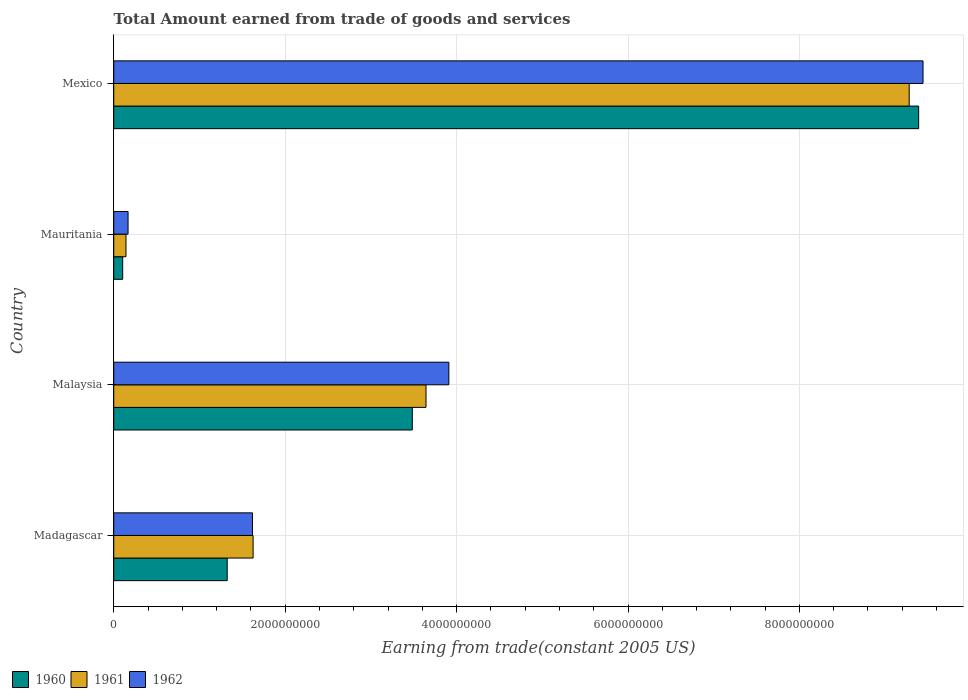How many different coloured bars are there?
Offer a very short reply. 3. How many groups of bars are there?
Ensure brevity in your answer.  4. Are the number of bars on each tick of the Y-axis equal?
Your answer should be compact. Yes. How many bars are there on the 1st tick from the bottom?
Ensure brevity in your answer.  3. What is the label of the 4th group of bars from the top?
Offer a terse response. Madagascar. What is the total amount earned by trading goods and services in 1961 in Mauritania?
Your answer should be compact. 1.43e+08. Across all countries, what is the maximum total amount earned by trading goods and services in 1960?
Your response must be concise. 9.39e+09. Across all countries, what is the minimum total amount earned by trading goods and services in 1962?
Your answer should be very brief. 1.67e+08. In which country was the total amount earned by trading goods and services in 1962 maximum?
Offer a very short reply. Mexico. In which country was the total amount earned by trading goods and services in 1960 minimum?
Make the answer very short. Mauritania. What is the total total amount earned by trading goods and services in 1960 in the graph?
Your answer should be very brief. 1.43e+1. What is the difference between the total amount earned by trading goods and services in 1961 in Madagascar and that in Mauritania?
Offer a very short reply. 1.48e+09. What is the difference between the total amount earned by trading goods and services in 1960 in Malaysia and the total amount earned by trading goods and services in 1962 in Mauritania?
Give a very brief answer. 3.32e+09. What is the average total amount earned by trading goods and services in 1962 per country?
Give a very brief answer. 3.78e+09. What is the difference between the total amount earned by trading goods and services in 1960 and total amount earned by trading goods and services in 1961 in Mauritania?
Offer a very short reply. -3.85e+07. In how many countries, is the total amount earned by trading goods and services in 1962 greater than 6800000000 US$?
Make the answer very short. 1. What is the ratio of the total amount earned by trading goods and services in 1960 in Madagascar to that in Mexico?
Provide a succinct answer. 0.14. Is the total amount earned by trading goods and services in 1960 in Mauritania less than that in Mexico?
Your answer should be very brief. Yes. What is the difference between the highest and the second highest total amount earned by trading goods and services in 1960?
Keep it short and to the point. 5.91e+09. What is the difference between the highest and the lowest total amount earned by trading goods and services in 1960?
Offer a very short reply. 9.29e+09. In how many countries, is the total amount earned by trading goods and services in 1962 greater than the average total amount earned by trading goods and services in 1962 taken over all countries?
Offer a terse response. 2. What does the 2nd bar from the top in Mauritania represents?
Make the answer very short. 1961. What does the 3rd bar from the bottom in Mexico represents?
Ensure brevity in your answer.  1962. Is it the case that in every country, the sum of the total amount earned by trading goods and services in 1962 and total amount earned by trading goods and services in 1960 is greater than the total amount earned by trading goods and services in 1961?
Offer a terse response. Yes. How many bars are there?
Your answer should be very brief. 12. Are all the bars in the graph horizontal?
Offer a terse response. Yes. How many countries are there in the graph?
Give a very brief answer. 4. Where does the legend appear in the graph?
Your response must be concise. Bottom left. What is the title of the graph?
Make the answer very short. Total Amount earned from trade of goods and services. What is the label or title of the X-axis?
Your answer should be very brief. Earning from trade(constant 2005 US). What is the label or title of the Y-axis?
Keep it short and to the point. Country. What is the Earning from trade(constant 2005 US) in 1960 in Madagascar?
Provide a succinct answer. 1.32e+09. What is the Earning from trade(constant 2005 US) in 1961 in Madagascar?
Provide a short and direct response. 1.63e+09. What is the Earning from trade(constant 2005 US) in 1962 in Madagascar?
Ensure brevity in your answer.  1.62e+09. What is the Earning from trade(constant 2005 US) in 1960 in Malaysia?
Provide a short and direct response. 3.48e+09. What is the Earning from trade(constant 2005 US) in 1961 in Malaysia?
Your answer should be compact. 3.64e+09. What is the Earning from trade(constant 2005 US) of 1962 in Malaysia?
Offer a terse response. 3.91e+09. What is the Earning from trade(constant 2005 US) in 1960 in Mauritania?
Offer a very short reply. 1.04e+08. What is the Earning from trade(constant 2005 US) in 1961 in Mauritania?
Your answer should be compact. 1.43e+08. What is the Earning from trade(constant 2005 US) in 1962 in Mauritania?
Your answer should be compact. 1.67e+08. What is the Earning from trade(constant 2005 US) in 1960 in Mexico?
Ensure brevity in your answer.  9.39e+09. What is the Earning from trade(constant 2005 US) of 1961 in Mexico?
Ensure brevity in your answer.  9.28e+09. What is the Earning from trade(constant 2005 US) of 1962 in Mexico?
Provide a succinct answer. 9.44e+09. Across all countries, what is the maximum Earning from trade(constant 2005 US) in 1960?
Give a very brief answer. 9.39e+09. Across all countries, what is the maximum Earning from trade(constant 2005 US) in 1961?
Your answer should be compact. 9.28e+09. Across all countries, what is the maximum Earning from trade(constant 2005 US) of 1962?
Make the answer very short. 9.44e+09. Across all countries, what is the minimum Earning from trade(constant 2005 US) of 1960?
Provide a succinct answer. 1.04e+08. Across all countries, what is the minimum Earning from trade(constant 2005 US) of 1961?
Your response must be concise. 1.43e+08. Across all countries, what is the minimum Earning from trade(constant 2005 US) of 1962?
Ensure brevity in your answer.  1.67e+08. What is the total Earning from trade(constant 2005 US) of 1960 in the graph?
Provide a succinct answer. 1.43e+1. What is the total Earning from trade(constant 2005 US) of 1961 in the graph?
Provide a short and direct response. 1.47e+1. What is the total Earning from trade(constant 2005 US) in 1962 in the graph?
Keep it short and to the point. 1.51e+1. What is the difference between the Earning from trade(constant 2005 US) of 1960 in Madagascar and that in Malaysia?
Your response must be concise. -2.16e+09. What is the difference between the Earning from trade(constant 2005 US) in 1961 in Madagascar and that in Malaysia?
Your answer should be very brief. -2.02e+09. What is the difference between the Earning from trade(constant 2005 US) in 1962 in Madagascar and that in Malaysia?
Your response must be concise. -2.29e+09. What is the difference between the Earning from trade(constant 2005 US) of 1960 in Madagascar and that in Mauritania?
Your answer should be very brief. 1.22e+09. What is the difference between the Earning from trade(constant 2005 US) in 1961 in Madagascar and that in Mauritania?
Make the answer very short. 1.48e+09. What is the difference between the Earning from trade(constant 2005 US) of 1962 in Madagascar and that in Mauritania?
Make the answer very short. 1.45e+09. What is the difference between the Earning from trade(constant 2005 US) in 1960 in Madagascar and that in Mexico?
Give a very brief answer. -8.07e+09. What is the difference between the Earning from trade(constant 2005 US) in 1961 in Madagascar and that in Mexico?
Your answer should be compact. -7.65e+09. What is the difference between the Earning from trade(constant 2005 US) in 1962 in Madagascar and that in Mexico?
Your answer should be very brief. -7.82e+09. What is the difference between the Earning from trade(constant 2005 US) of 1960 in Malaysia and that in Mauritania?
Your answer should be compact. 3.38e+09. What is the difference between the Earning from trade(constant 2005 US) of 1961 in Malaysia and that in Mauritania?
Your response must be concise. 3.50e+09. What is the difference between the Earning from trade(constant 2005 US) of 1962 in Malaysia and that in Mauritania?
Offer a very short reply. 3.74e+09. What is the difference between the Earning from trade(constant 2005 US) of 1960 in Malaysia and that in Mexico?
Provide a short and direct response. -5.91e+09. What is the difference between the Earning from trade(constant 2005 US) of 1961 in Malaysia and that in Mexico?
Provide a succinct answer. -5.64e+09. What is the difference between the Earning from trade(constant 2005 US) of 1962 in Malaysia and that in Mexico?
Keep it short and to the point. -5.53e+09. What is the difference between the Earning from trade(constant 2005 US) of 1960 in Mauritania and that in Mexico?
Keep it short and to the point. -9.29e+09. What is the difference between the Earning from trade(constant 2005 US) of 1961 in Mauritania and that in Mexico?
Give a very brief answer. -9.14e+09. What is the difference between the Earning from trade(constant 2005 US) of 1962 in Mauritania and that in Mexico?
Make the answer very short. -9.28e+09. What is the difference between the Earning from trade(constant 2005 US) in 1960 in Madagascar and the Earning from trade(constant 2005 US) in 1961 in Malaysia?
Ensure brevity in your answer.  -2.32e+09. What is the difference between the Earning from trade(constant 2005 US) in 1960 in Madagascar and the Earning from trade(constant 2005 US) in 1962 in Malaysia?
Provide a succinct answer. -2.59e+09. What is the difference between the Earning from trade(constant 2005 US) of 1961 in Madagascar and the Earning from trade(constant 2005 US) of 1962 in Malaysia?
Your answer should be very brief. -2.28e+09. What is the difference between the Earning from trade(constant 2005 US) of 1960 in Madagascar and the Earning from trade(constant 2005 US) of 1961 in Mauritania?
Offer a terse response. 1.18e+09. What is the difference between the Earning from trade(constant 2005 US) of 1960 in Madagascar and the Earning from trade(constant 2005 US) of 1962 in Mauritania?
Keep it short and to the point. 1.16e+09. What is the difference between the Earning from trade(constant 2005 US) in 1961 in Madagascar and the Earning from trade(constant 2005 US) in 1962 in Mauritania?
Your response must be concise. 1.46e+09. What is the difference between the Earning from trade(constant 2005 US) in 1960 in Madagascar and the Earning from trade(constant 2005 US) in 1961 in Mexico?
Offer a terse response. -7.96e+09. What is the difference between the Earning from trade(constant 2005 US) of 1960 in Madagascar and the Earning from trade(constant 2005 US) of 1962 in Mexico?
Offer a terse response. -8.12e+09. What is the difference between the Earning from trade(constant 2005 US) of 1961 in Madagascar and the Earning from trade(constant 2005 US) of 1962 in Mexico?
Make the answer very short. -7.82e+09. What is the difference between the Earning from trade(constant 2005 US) in 1960 in Malaysia and the Earning from trade(constant 2005 US) in 1961 in Mauritania?
Keep it short and to the point. 3.34e+09. What is the difference between the Earning from trade(constant 2005 US) of 1960 in Malaysia and the Earning from trade(constant 2005 US) of 1962 in Mauritania?
Ensure brevity in your answer.  3.32e+09. What is the difference between the Earning from trade(constant 2005 US) of 1961 in Malaysia and the Earning from trade(constant 2005 US) of 1962 in Mauritania?
Provide a succinct answer. 3.48e+09. What is the difference between the Earning from trade(constant 2005 US) in 1960 in Malaysia and the Earning from trade(constant 2005 US) in 1961 in Mexico?
Your answer should be very brief. -5.80e+09. What is the difference between the Earning from trade(constant 2005 US) in 1960 in Malaysia and the Earning from trade(constant 2005 US) in 1962 in Mexico?
Offer a terse response. -5.96e+09. What is the difference between the Earning from trade(constant 2005 US) in 1961 in Malaysia and the Earning from trade(constant 2005 US) in 1962 in Mexico?
Make the answer very short. -5.80e+09. What is the difference between the Earning from trade(constant 2005 US) of 1960 in Mauritania and the Earning from trade(constant 2005 US) of 1961 in Mexico?
Provide a short and direct response. -9.18e+09. What is the difference between the Earning from trade(constant 2005 US) of 1960 in Mauritania and the Earning from trade(constant 2005 US) of 1962 in Mexico?
Keep it short and to the point. -9.34e+09. What is the difference between the Earning from trade(constant 2005 US) of 1961 in Mauritania and the Earning from trade(constant 2005 US) of 1962 in Mexico?
Provide a succinct answer. -9.30e+09. What is the average Earning from trade(constant 2005 US) in 1960 per country?
Offer a terse response. 3.58e+09. What is the average Earning from trade(constant 2005 US) in 1961 per country?
Keep it short and to the point. 3.67e+09. What is the average Earning from trade(constant 2005 US) of 1962 per country?
Your answer should be very brief. 3.78e+09. What is the difference between the Earning from trade(constant 2005 US) of 1960 and Earning from trade(constant 2005 US) of 1961 in Madagascar?
Provide a succinct answer. -3.02e+08. What is the difference between the Earning from trade(constant 2005 US) in 1960 and Earning from trade(constant 2005 US) in 1962 in Madagascar?
Provide a succinct answer. -2.95e+08. What is the difference between the Earning from trade(constant 2005 US) of 1961 and Earning from trade(constant 2005 US) of 1962 in Madagascar?
Provide a succinct answer. 7.38e+06. What is the difference between the Earning from trade(constant 2005 US) in 1960 and Earning from trade(constant 2005 US) in 1961 in Malaysia?
Your response must be concise. -1.60e+08. What is the difference between the Earning from trade(constant 2005 US) in 1960 and Earning from trade(constant 2005 US) in 1962 in Malaysia?
Offer a very short reply. -4.26e+08. What is the difference between the Earning from trade(constant 2005 US) in 1961 and Earning from trade(constant 2005 US) in 1962 in Malaysia?
Provide a short and direct response. -2.67e+08. What is the difference between the Earning from trade(constant 2005 US) in 1960 and Earning from trade(constant 2005 US) in 1961 in Mauritania?
Offer a very short reply. -3.85e+07. What is the difference between the Earning from trade(constant 2005 US) in 1960 and Earning from trade(constant 2005 US) in 1962 in Mauritania?
Ensure brevity in your answer.  -6.27e+07. What is the difference between the Earning from trade(constant 2005 US) of 1961 and Earning from trade(constant 2005 US) of 1962 in Mauritania?
Ensure brevity in your answer.  -2.42e+07. What is the difference between the Earning from trade(constant 2005 US) in 1960 and Earning from trade(constant 2005 US) in 1961 in Mexico?
Your response must be concise. 1.10e+08. What is the difference between the Earning from trade(constant 2005 US) of 1960 and Earning from trade(constant 2005 US) of 1962 in Mexico?
Make the answer very short. -5.10e+07. What is the difference between the Earning from trade(constant 2005 US) in 1961 and Earning from trade(constant 2005 US) in 1962 in Mexico?
Make the answer very short. -1.61e+08. What is the ratio of the Earning from trade(constant 2005 US) in 1960 in Madagascar to that in Malaysia?
Offer a very short reply. 0.38. What is the ratio of the Earning from trade(constant 2005 US) in 1961 in Madagascar to that in Malaysia?
Your response must be concise. 0.45. What is the ratio of the Earning from trade(constant 2005 US) in 1962 in Madagascar to that in Malaysia?
Provide a short and direct response. 0.41. What is the ratio of the Earning from trade(constant 2005 US) in 1960 in Madagascar to that in Mauritania?
Your answer should be very brief. 12.69. What is the ratio of the Earning from trade(constant 2005 US) of 1961 in Madagascar to that in Mauritania?
Provide a succinct answer. 11.38. What is the ratio of the Earning from trade(constant 2005 US) in 1962 in Madagascar to that in Mauritania?
Offer a very short reply. 9.69. What is the ratio of the Earning from trade(constant 2005 US) in 1960 in Madagascar to that in Mexico?
Make the answer very short. 0.14. What is the ratio of the Earning from trade(constant 2005 US) in 1961 in Madagascar to that in Mexico?
Make the answer very short. 0.18. What is the ratio of the Earning from trade(constant 2005 US) in 1962 in Madagascar to that in Mexico?
Provide a succinct answer. 0.17. What is the ratio of the Earning from trade(constant 2005 US) of 1960 in Malaysia to that in Mauritania?
Your answer should be very brief. 33.39. What is the ratio of the Earning from trade(constant 2005 US) of 1961 in Malaysia to that in Mauritania?
Your response must be concise. 25.51. What is the ratio of the Earning from trade(constant 2005 US) in 1962 in Malaysia to that in Mauritania?
Your response must be concise. 23.41. What is the ratio of the Earning from trade(constant 2005 US) in 1960 in Malaysia to that in Mexico?
Offer a very short reply. 0.37. What is the ratio of the Earning from trade(constant 2005 US) in 1961 in Malaysia to that in Mexico?
Provide a short and direct response. 0.39. What is the ratio of the Earning from trade(constant 2005 US) in 1962 in Malaysia to that in Mexico?
Ensure brevity in your answer.  0.41. What is the ratio of the Earning from trade(constant 2005 US) of 1960 in Mauritania to that in Mexico?
Give a very brief answer. 0.01. What is the ratio of the Earning from trade(constant 2005 US) of 1961 in Mauritania to that in Mexico?
Provide a succinct answer. 0.02. What is the ratio of the Earning from trade(constant 2005 US) of 1962 in Mauritania to that in Mexico?
Your response must be concise. 0.02. What is the difference between the highest and the second highest Earning from trade(constant 2005 US) in 1960?
Your answer should be very brief. 5.91e+09. What is the difference between the highest and the second highest Earning from trade(constant 2005 US) of 1961?
Give a very brief answer. 5.64e+09. What is the difference between the highest and the second highest Earning from trade(constant 2005 US) of 1962?
Make the answer very short. 5.53e+09. What is the difference between the highest and the lowest Earning from trade(constant 2005 US) of 1960?
Provide a short and direct response. 9.29e+09. What is the difference between the highest and the lowest Earning from trade(constant 2005 US) of 1961?
Provide a short and direct response. 9.14e+09. What is the difference between the highest and the lowest Earning from trade(constant 2005 US) of 1962?
Make the answer very short. 9.28e+09. 